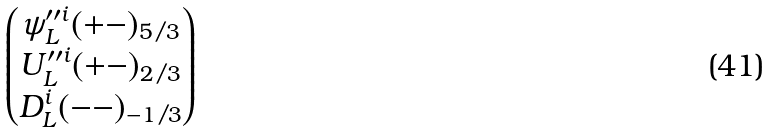Convert formula to latex. <formula><loc_0><loc_0><loc_500><loc_500>\begin{pmatrix} \psi ^ { \prime \prime i } _ { L } ( + - ) _ { 5 / 3 } \\ U ^ { \prime \prime i } _ { L } ( + - ) _ { 2 / 3 } \\ D ^ { i } _ { L } ( - - ) _ { - 1 / 3 } \end{pmatrix}</formula> 